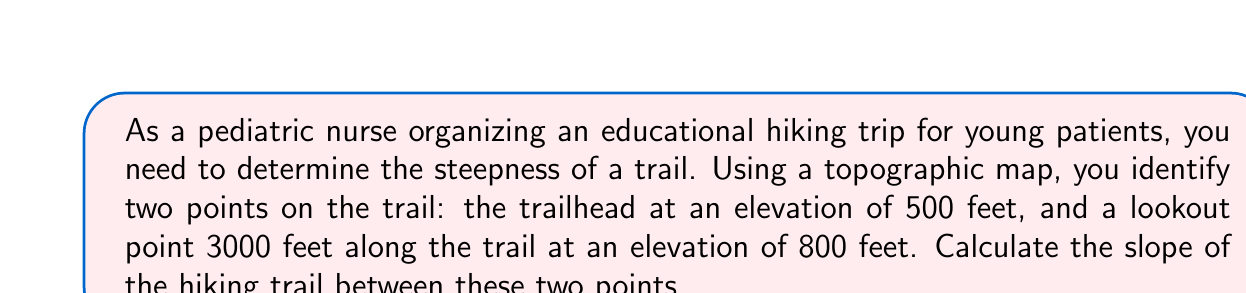Solve this math problem. To calculate the slope of the hiking trail, we'll use the slope formula:

$$ \text{Slope} = \frac{\text{rise}}{\text{run}} = \frac{\text{change in y}}{\text{change in x}} = \frac{y_2 - y_1}{x_2 - x_1} $$

Let's identify our points:
- Point 1 (trailhead): $(x_1, y_1) = (0, 500)$
- Point 2 (lookout): $(x_2, y_2) = (3000, 800)$

Now, let's substitute these values into the slope formula:

$$ \text{Slope} = \frac{800 - 500}{3000 - 0} = \frac{300}{3000} $$

Simplify the fraction:

$$ \text{Slope} = \frac{1}{10} = 0.1 $$

This means that for every 10 feet of horizontal distance, the trail rises 1 foot in elevation.

To express this as a percentage, multiply by 100:

$$ 0.1 \times 100 = 10\% $$

Therefore, the slope of the hiking trail is 0.1 or 10%.
Answer: The slope of the hiking trail is 0.1 or 10%. 